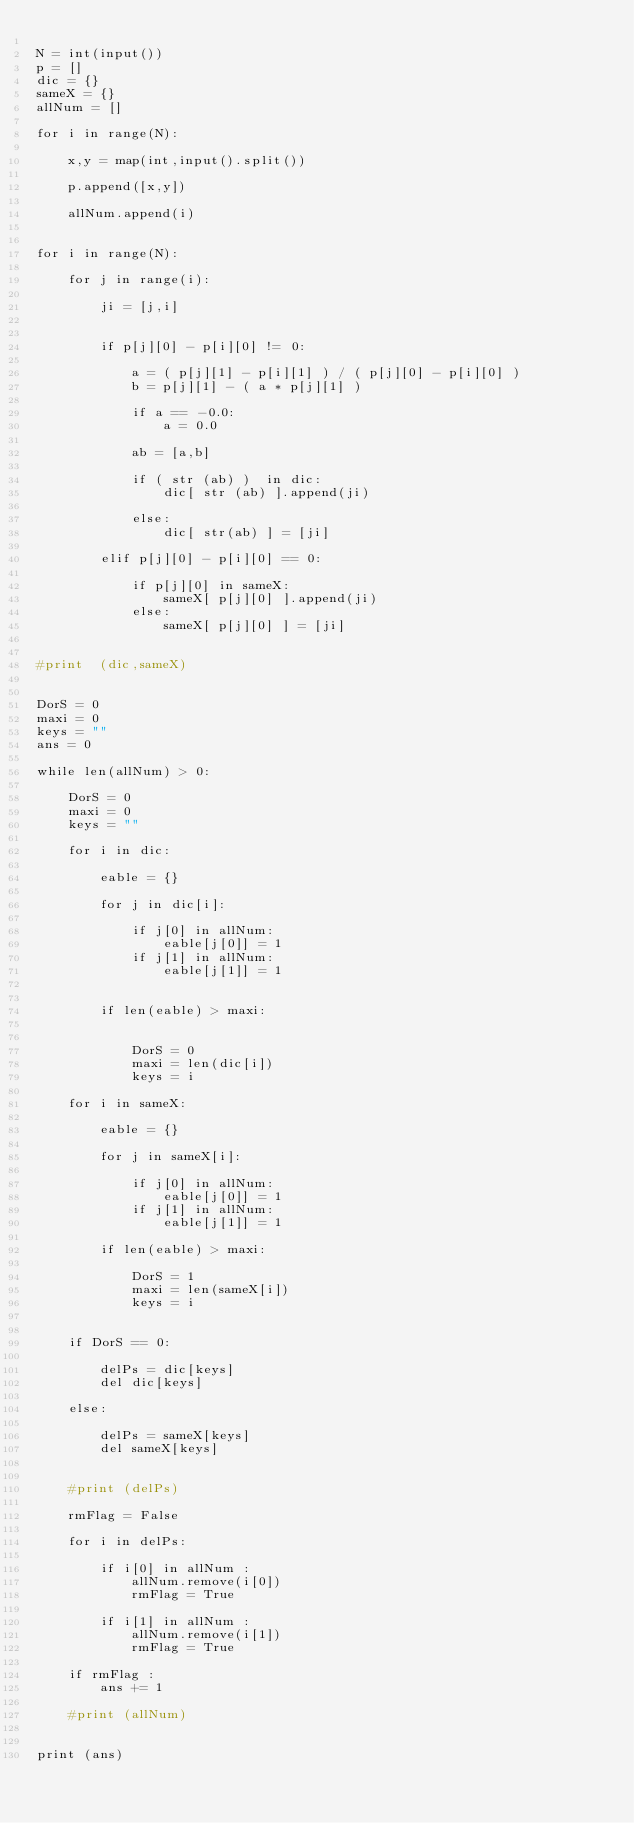Convert code to text. <code><loc_0><loc_0><loc_500><loc_500><_Python_>
N = int(input())
p = []
dic = {}
sameX = {}
allNum = []

for i in range(N):

    x,y = map(int,input().split())

    p.append([x,y])

    allNum.append(i)


for i in range(N):

    for j in range(i):

        ji = [j,i]
        

        if p[j][0] - p[i][0] != 0:

            a = ( p[j][1] - p[i][1] ) / ( p[j][0] - p[i][0] )
            b = p[j][1] - ( a * p[j][1] )

            if a == -0.0:
                a = 0.0
            
            ab = [a,b]

            if ( str (ab) )  in dic:
                dic[ str (ab) ].append(ji)

            else:
                dic[ str(ab) ] = [ji]

        elif p[j][0] - p[i][0] == 0:

            if p[j][0] in sameX:
                sameX[ p[j][0] ].append(ji)
            else:
                sameX[ p[j][0] ] = [ji]
            

#print  (dic,sameX)
        

DorS = 0
maxi = 0
keys = ""
ans = 0

while len(allNum) > 0:

    DorS = 0
    maxi = 0
    keys = ""

    for i in dic:
        
        eable = {}
        
        for j in dic[i]:

            if j[0] in allNum:
                eable[j[0]] = 1
            if j[1] in allNum:
                eable[j[1]] = 1            
                

        if len(eable) > maxi:

            
            DorS = 0
            maxi = len(dic[i])
            keys = i

    for i in sameX:

        eable = {}

        for j in sameX[i]:

            if j[0] in allNum:
                eable[j[0]] = 1
            if j[1] in allNum:
                eable[j[1]] = 1            

        if len(eable) > maxi:

            DorS = 1
            maxi = len(sameX[i])
            keys = i


    if DorS == 0:

        delPs = dic[keys]
        del dic[keys]

    else:

        delPs = sameX[keys]
        del sameX[keys]


    #print (delPs)

    rmFlag = False

    for i in delPs:

        if i[0] in allNum :
            allNum.remove(i[0])
            rmFlag = True

        if i[1] in allNum :
            allNum.remove(i[1])
            rmFlag = True

    if rmFlag :
        ans += 1

    #print (allNum)

        
print (ans)
</code> 